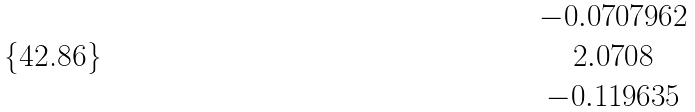<formula> <loc_0><loc_0><loc_500><loc_500>\begin{matrix} - 0 . 0 7 0 7 9 6 2 \\ 2 . 0 7 0 8 \\ - 0 . 1 1 9 6 3 5 \end{matrix}</formula> 